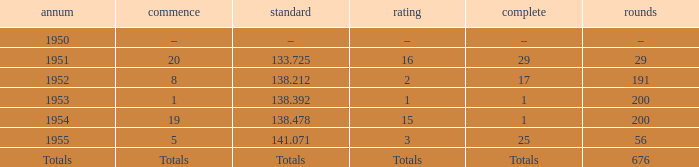What finish qualified at 141.071? 25.0. 